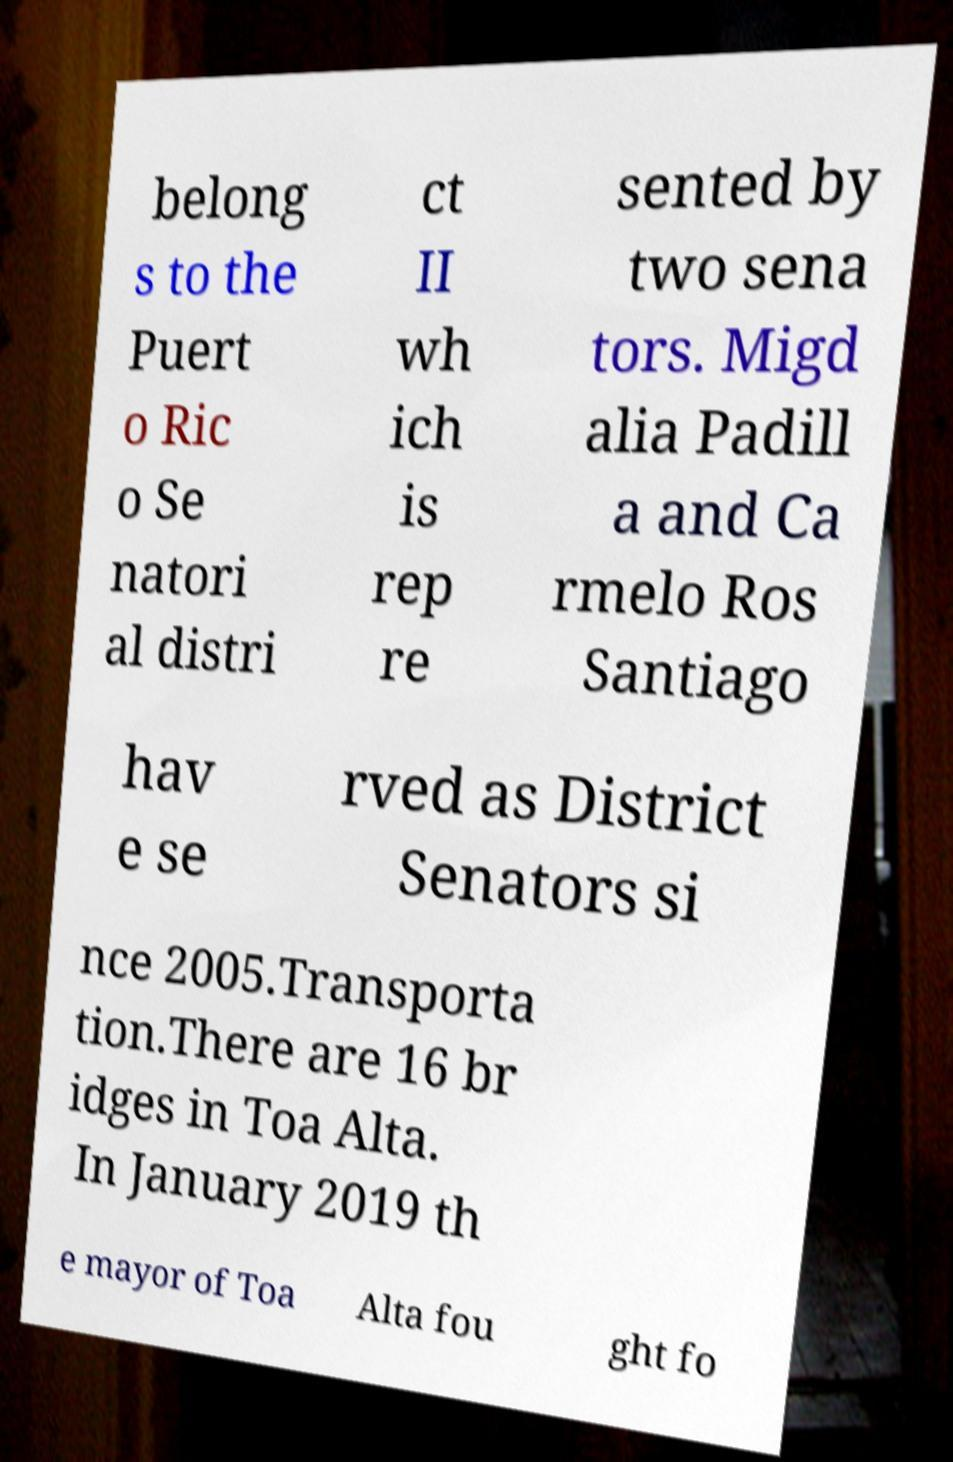For documentation purposes, I need the text within this image transcribed. Could you provide that? belong s to the Puert o Ric o Se natori al distri ct II wh ich is rep re sented by two sena tors. Migd alia Padill a and Ca rmelo Ros Santiago hav e se rved as District Senators si nce 2005.Transporta tion.There are 16 br idges in Toa Alta. In January 2019 th e mayor of Toa Alta fou ght fo 